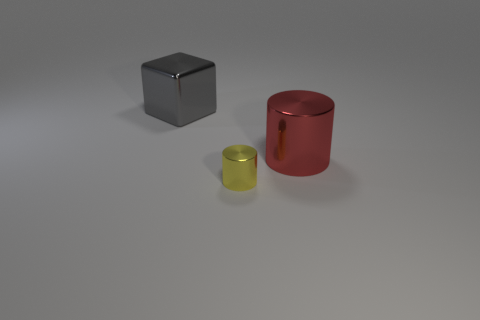Do the metal cylinder that is behind the yellow cylinder and the small thing have the same size?
Ensure brevity in your answer.  No. What color is the thing that is both in front of the block and behind the tiny yellow object?
Offer a very short reply. Red. What number of gray things are in front of the object that is behind the large cylinder?
Make the answer very short. 0. Is the large red thing the same shape as the yellow metallic object?
Provide a short and direct response. Yes. Is there anything else that is the same color as the small shiny thing?
Ensure brevity in your answer.  No. There is a tiny yellow metallic thing; is its shape the same as the large metallic object that is right of the large gray metal cube?
Provide a succinct answer. Yes. The object that is in front of the metal cylinder that is right of the thing in front of the red metallic object is what color?
Ensure brevity in your answer.  Yellow. Is there any other thing that has the same material as the large gray cube?
Keep it short and to the point. Yes. There is a large object to the right of the gray cube; is its shape the same as the yellow thing?
Ensure brevity in your answer.  Yes. What is the material of the red object?
Your response must be concise. Metal. 